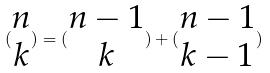Convert formula to latex. <formula><loc_0><loc_0><loc_500><loc_500>( \begin{matrix} n \\ k \end{matrix} ) = ( \begin{matrix} n - 1 \\ k \end{matrix} ) + ( \begin{matrix} n - 1 \\ k - 1 \end{matrix} )</formula> 